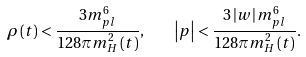<formula> <loc_0><loc_0><loc_500><loc_500>\rho \left ( t \right ) < \frac { 3 m _ { p l } ^ { 6 } } { 1 2 8 \pi m _ { H } ^ { 2 } \left ( t \right ) } , \quad \left | p \right | < \frac { 3 \left | w \right | m _ { p l } ^ { 6 } } { 1 2 8 \pi m _ { H } ^ { 2 } \left ( t \right ) } .</formula> 